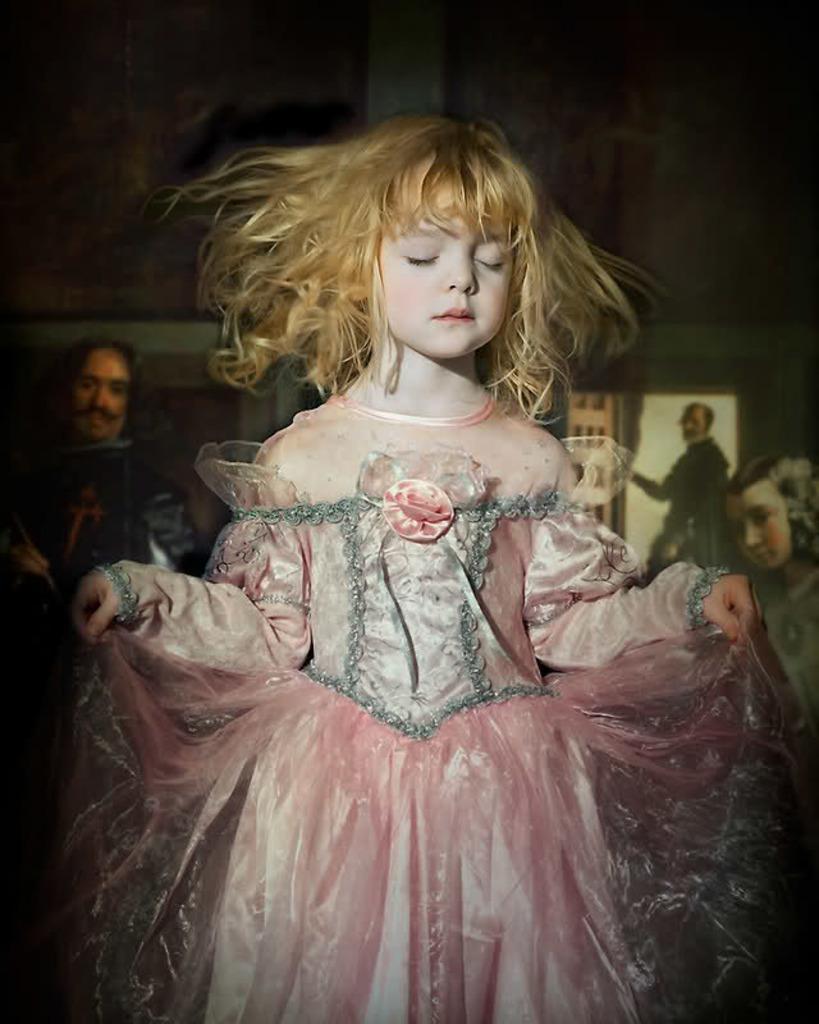Could you give a brief overview of what you see in this image? In this image I can see a child wearing pink and ash color dress. Back I can see few painted pictures and dark background. 